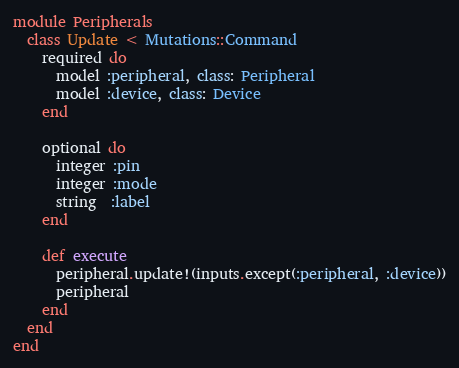<code> <loc_0><loc_0><loc_500><loc_500><_Ruby_>module Peripherals
  class Update < Mutations::Command
    required do
      model :peripheral, class: Peripheral
      model :device, class: Device
    end

    optional do
      integer :pin
      integer :mode
      string  :label
    end

    def execute
      peripheral.update!(inputs.except(:peripheral, :device))
      peripheral
    end
  end
end
</code> 